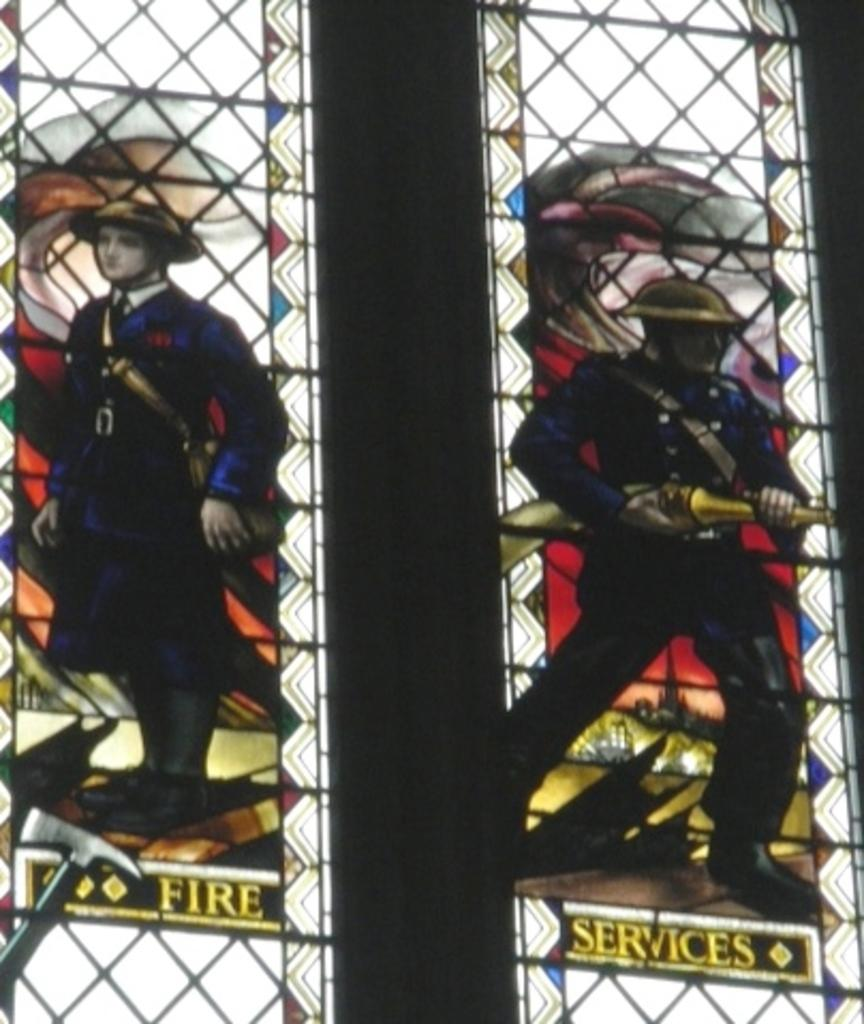What is written or printed on the glass of the windows in the image? There are words on the glass of the windows in the image. Can you describe the images on the glass of the windows? There are photos of two persons on the glass of the windows. What type of architectural feature is present in the image? There are iron grilles in the image. What type of wood can be seen in the image? There is no wood present in the image; it features words, photos, and iron grilles on the windows. How does the rod function in the image? There is no rod present in the image. 